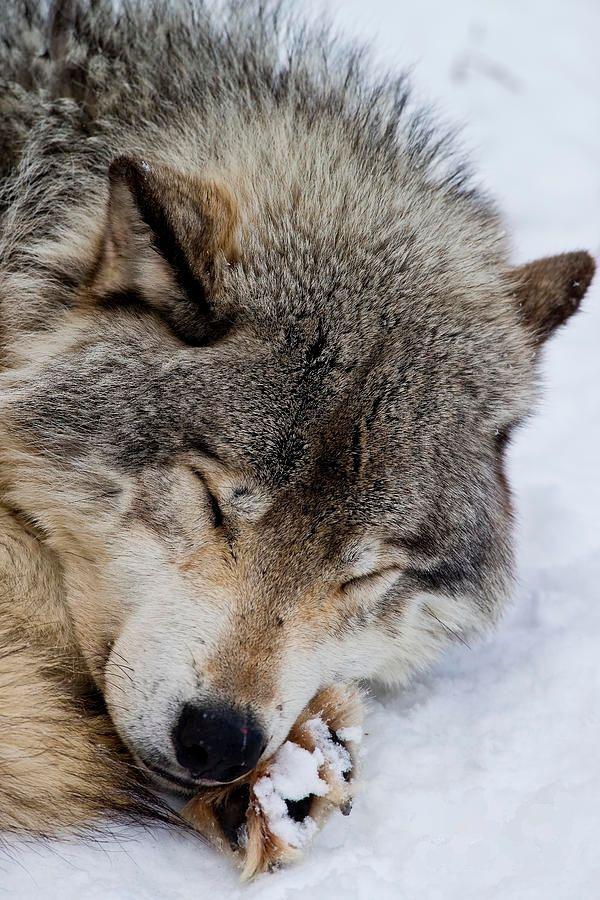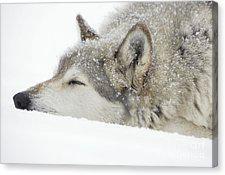The first image is the image on the left, the second image is the image on the right. Assess this claim about the two images: "One image contains two wolves standing up, and the other contains one wolf sleeping peacefully.". Correct or not? Answer yes or no. No. The first image is the image on the left, the second image is the image on the right. Assess this claim about the two images: "One image shows two awake, open-eyed wolves posed close together and similarly.". Correct or not? Answer yes or no. No. 